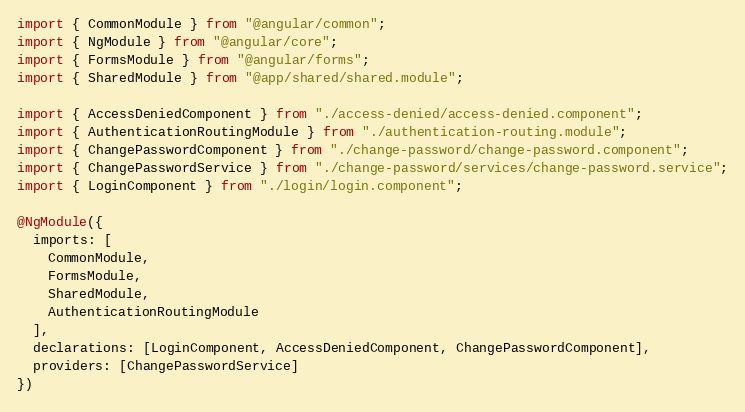<code> <loc_0><loc_0><loc_500><loc_500><_TypeScript_>import { CommonModule } from "@angular/common";
import { NgModule } from "@angular/core";
import { FormsModule } from "@angular/forms";
import { SharedModule } from "@app/shared/shared.module";

import { AccessDeniedComponent } from "./access-denied/access-denied.component";
import { AuthenticationRoutingModule } from "./authentication-routing.module";
import { ChangePasswordComponent } from "./change-password/change-password.component";
import { ChangePasswordService } from "./change-password/services/change-password.service";
import { LoginComponent } from "./login/login.component";

@NgModule({
  imports: [
    CommonModule,
    FormsModule,
    SharedModule,
    AuthenticationRoutingModule
  ],
  declarations: [LoginComponent, AccessDeniedComponent, ChangePasswordComponent],
  providers: [ChangePasswordService]
})</code> 